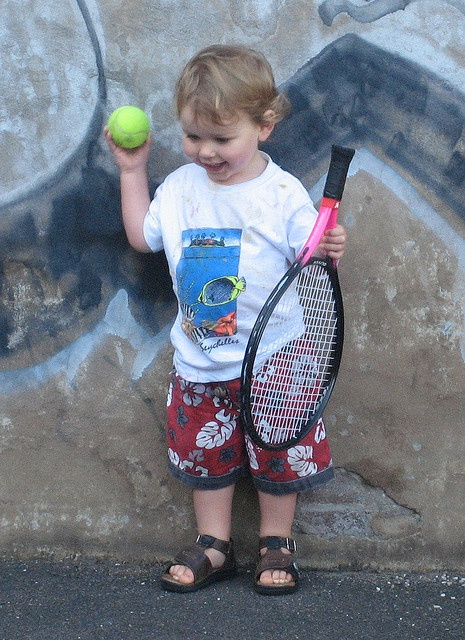Describe the objects in this image and their specific colors. I can see people in darkgray, lavender, and gray tones, tennis racket in darkgray, black, lavender, gray, and lightblue tones, and sports ball in darkgray, lightgreen, and olive tones in this image. 